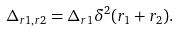<formula> <loc_0><loc_0><loc_500><loc_500>\Delta _ { { r } 1 , { r } 2 } = \Delta _ { { r } 1 } \delta ^ { 2 } ( { r } _ { 1 } + { r } _ { 2 } ) .</formula> 